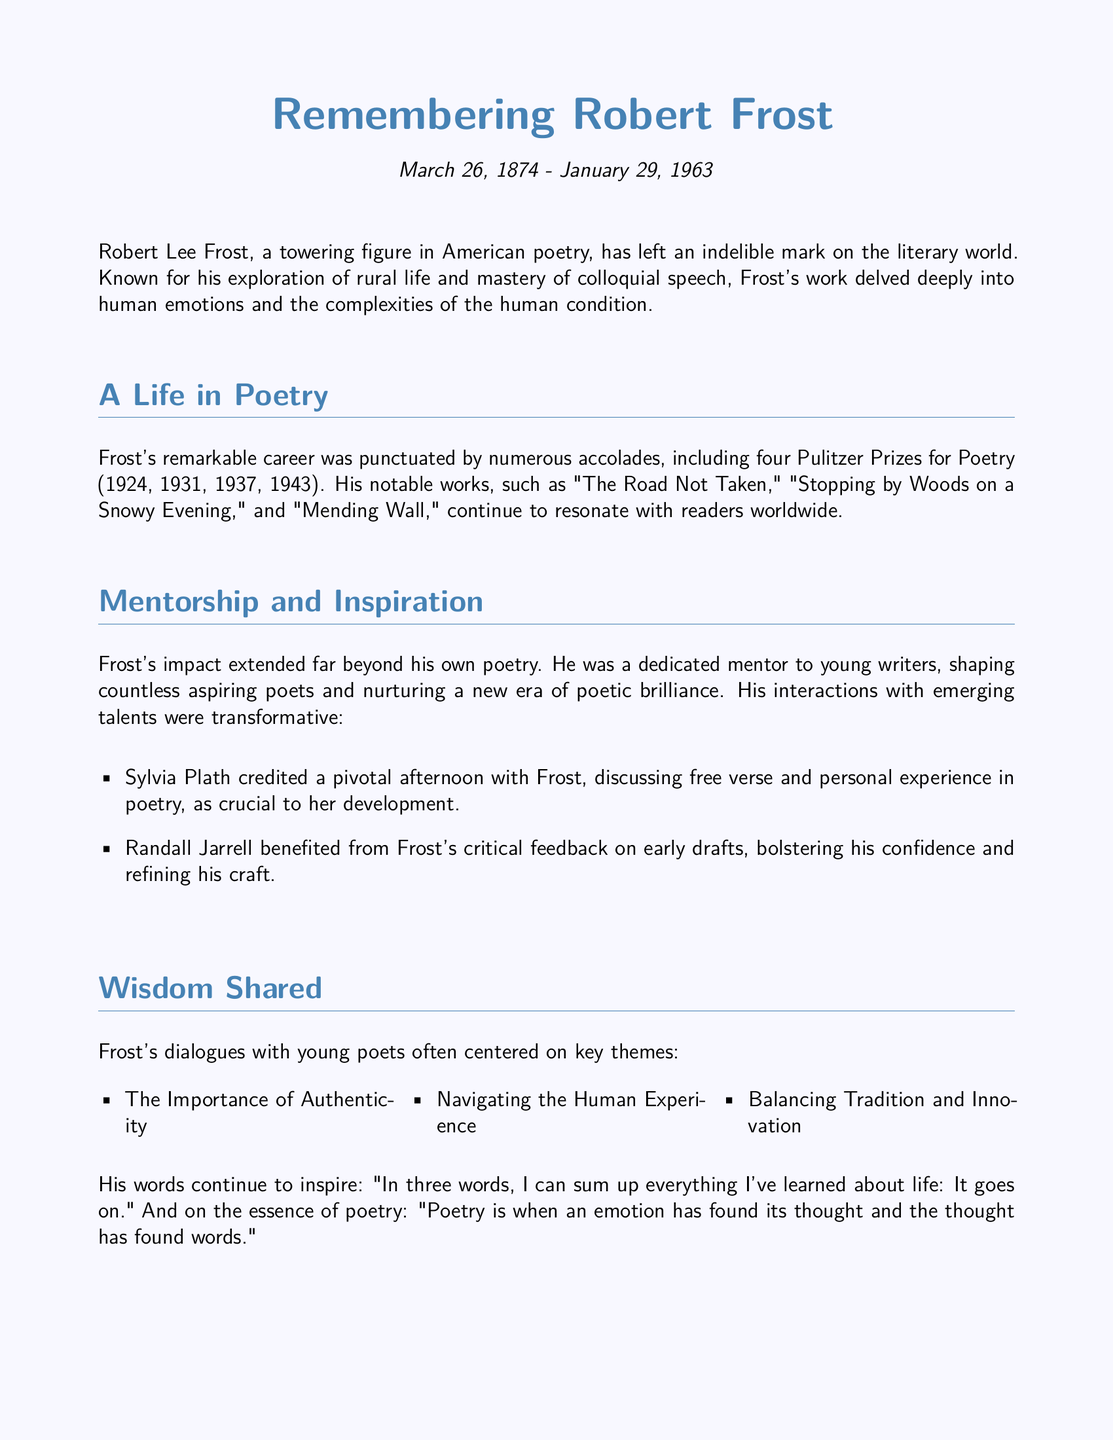what were the dates of Robert Frost's life? The document provides specific birth and death dates for Robert Frost as March 26, 1874 - January 29, 1963.
Answer: March 26, 1874 - January 29, 1963 how many Pulitzer Prizes did Frost win? The document states that Frost won four Pulitzer Prizes for Poetry during his career.
Answer: four which work of Frost is mentioned first in the document? The first notable work of Frost mentioned in the document is "The Road Not Taken."
Answer: "The Road Not Taken" who credited Frost for a pivotal afternoon? The document states that Sylvia Plath credited a pivotal afternoon with Frost as crucial to her development.
Answer: Sylvia Plath what is one key theme discussed in Frost's dialogues with young poets? The document lists key themes from Frost's dialogues, including the Importance of Authenticity.
Answer: Importance of Authenticity how did Frost influence Randall Jarrell? The document mentions that Frost provided critical feedback on early drafts, which helped bolster Jarrell's confidence.
Answer: critical feedback what is emphasized at the Bread Loaf Writers' Conference? The document highlights that Frost's lectures emphasized the importance of finding one's unique voice.
Answer: unique voice what is a famous quote about life attributed to Frost in the document? The document mentions the quote by Frost: "In three words, I can sum up everything I've learned about life: It goes on."
Answer: "It goes on." what does the document state about Frost's legacy? The document concludes that Frost's legacy continues to inspire new generations of poets through those he has influenced.
Answer: inspires new generations 